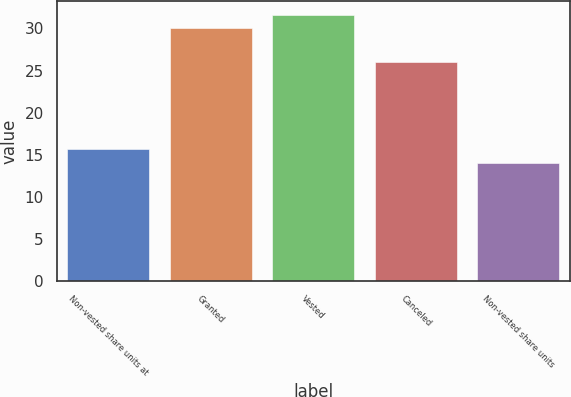Convert chart. <chart><loc_0><loc_0><loc_500><loc_500><bar_chart><fcel>Non-vested share units at<fcel>Granted<fcel>Vested<fcel>Canceled<fcel>Non-vested share units<nl><fcel>15.67<fcel>30.03<fcel>31.65<fcel>26<fcel>14.02<nl></chart> 